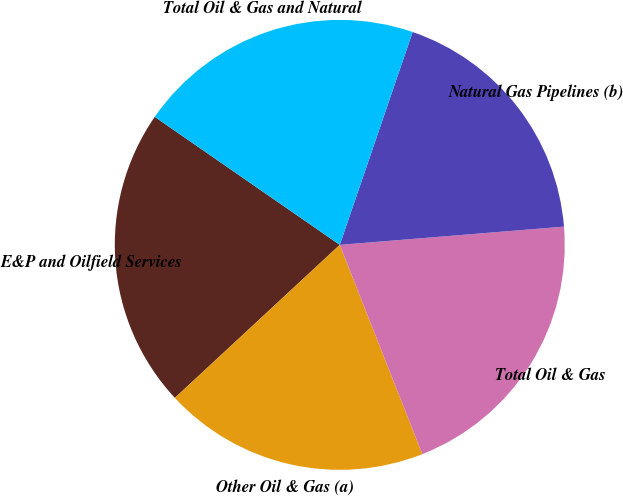<chart> <loc_0><loc_0><loc_500><loc_500><pie_chart><fcel>E&P and Oilfield Services<fcel>Other Oil & Gas (a)<fcel>Total Oil & Gas<fcel>Natural Gas Pipelines (b)<fcel>Total Oil & Gas and Natural<nl><fcel>21.54%<fcel>19.08%<fcel>20.31%<fcel>18.46%<fcel>20.62%<nl></chart> 